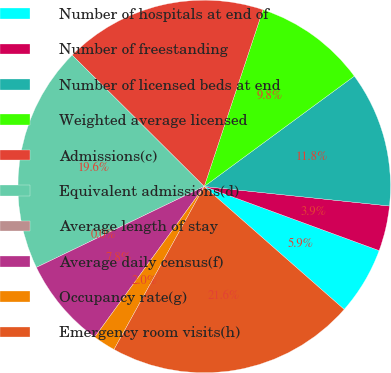Convert chart to OTSL. <chart><loc_0><loc_0><loc_500><loc_500><pie_chart><fcel>Number of hospitals at end of<fcel>Number of freestanding<fcel>Number of licensed beds at end<fcel>Weighted average licensed<fcel>Admissions(c)<fcel>Equivalent admissions(d)<fcel>Average length of stay<fcel>Average daily census(f)<fcel>Occupancy rate(g)<fcel>Emergency room visits(h)<nl><fcel>5.88%<fcel>3.92%<fcel>11.76%<fcel>9.8%<fcel>17.65%<fcel>19.61%<fcel>0.0%<fcel>7.84%<fcel>1.96%<fcel>21.57%<nl></chart> 